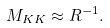<formula> <loc_0><loc_0><loc_500><loc_500>M _ { K K } \approx R ^ { - 1 } .</formula> 